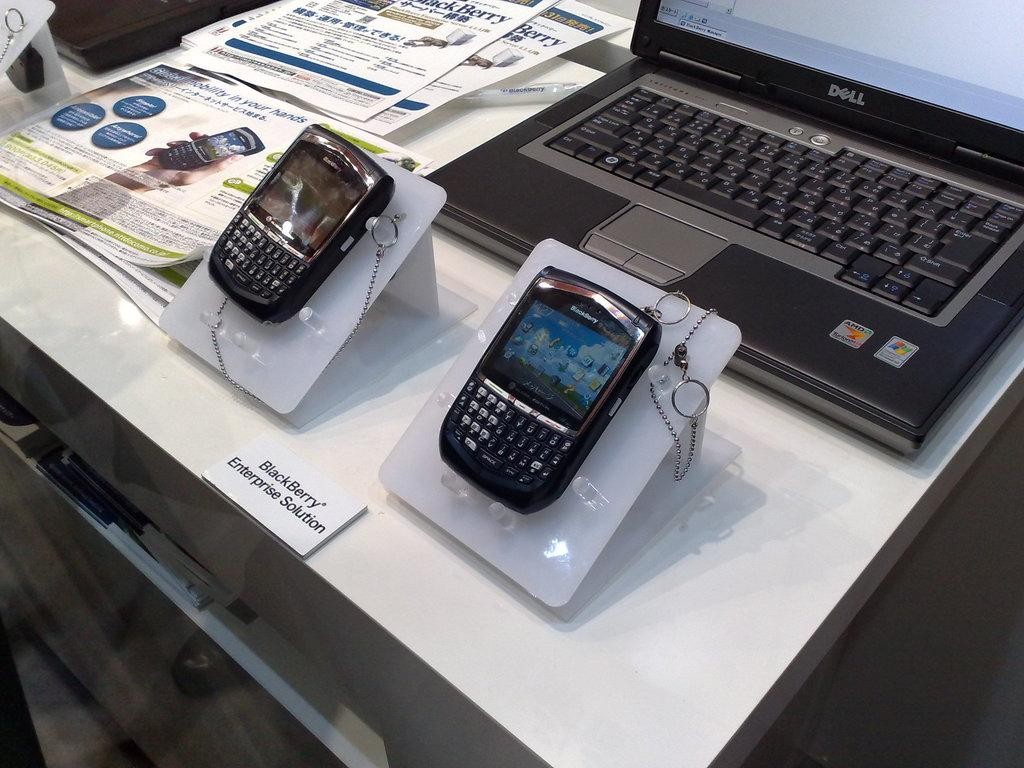<image>
Provide a brief description of the given image. A Blackberry device sits in front of a laptop. 